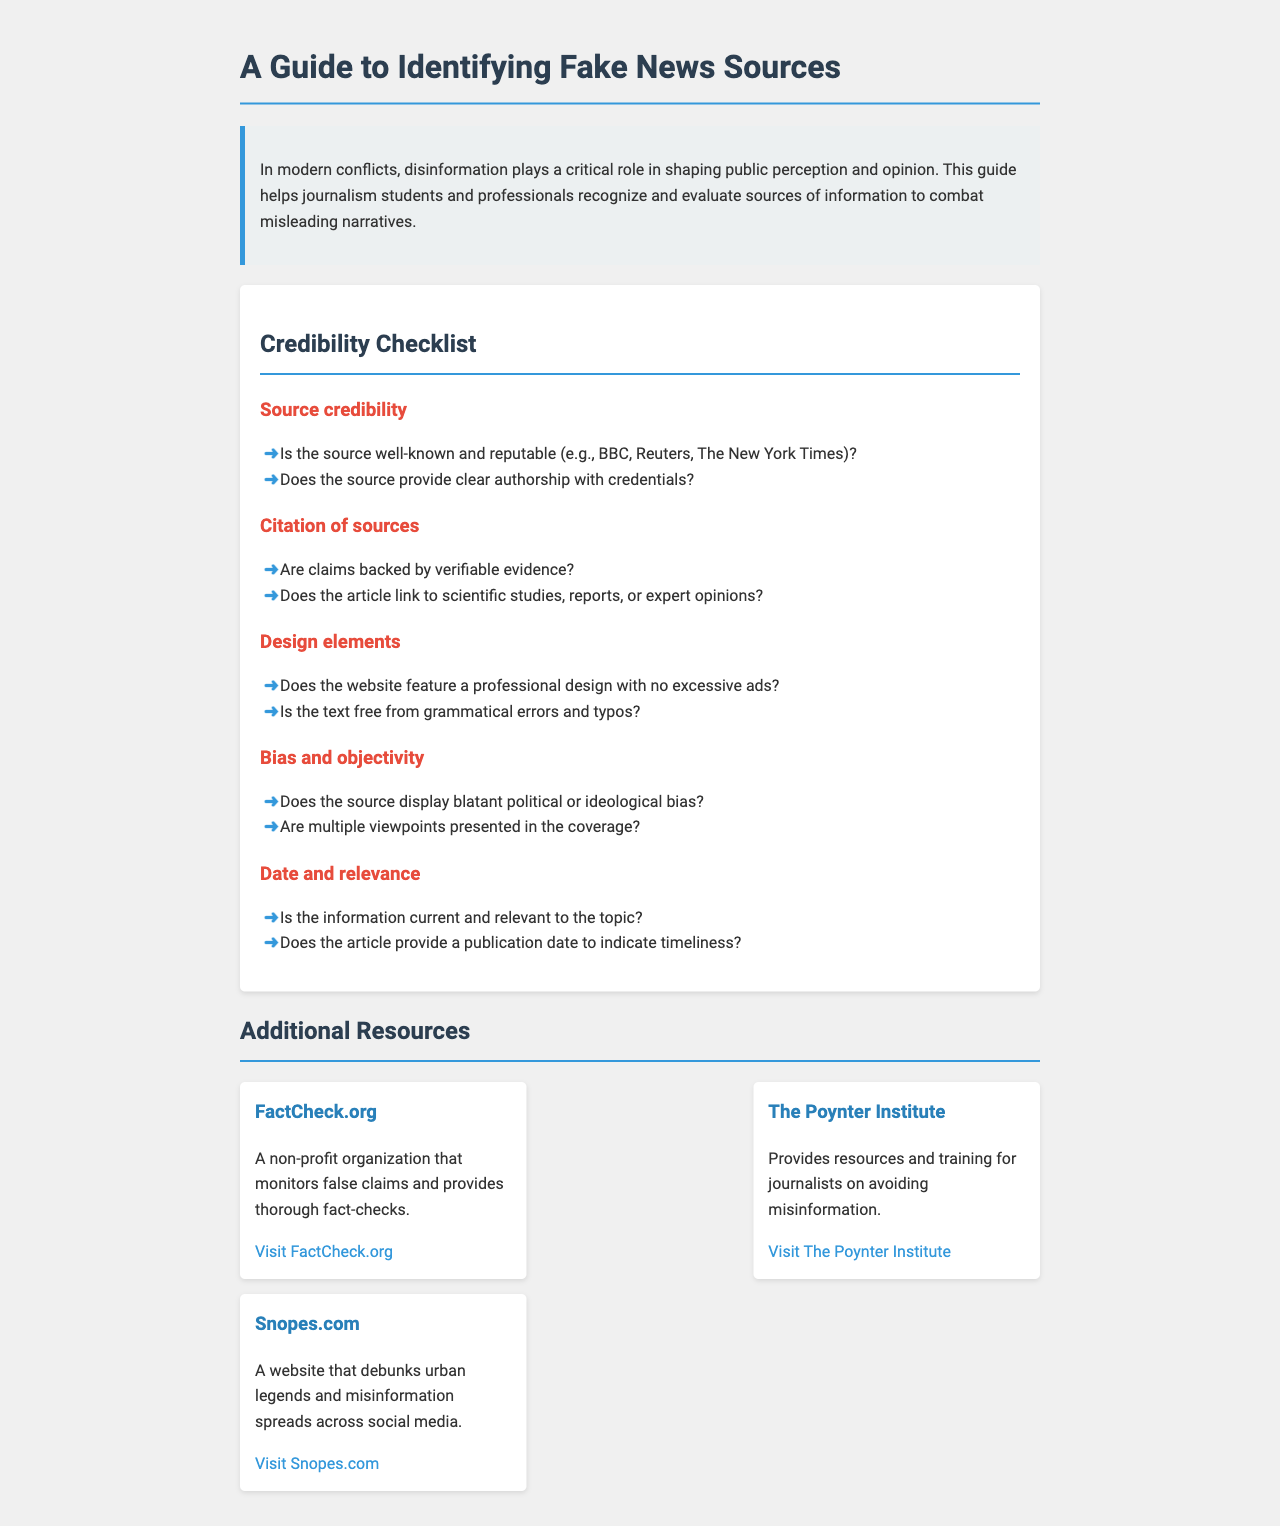What is the title of the document? The title provides the primary subject of the document and is stated at the top.
Answer: A Guide to Identifying Fake News Sources What does the introduction highlight about disinformation? The introduction explains the role of disinformation specifically in modern conflicts.
Answer: It plays a critical role in shaping public perception and opinion Name one of the resources listed in the document. The document provides a list of organizations that help combat misinformation.
Answer: FactCheck.org How many items are in the credibility checklist? The document explicitly indicates the number of checklist items provided under the Credibility Checklist section.
Answer: Five What color is used for headings in the checklist? The checklist uses a consistent color scheme for its headers to maintain design cohesion.
Answer: Red What does a professional website design lack according to the checklist? According to the layout guidelines in the checklist, a professional design should not contain certain elements that detract from credibility.
Answer: Excessive ads What type of bias does the checklist ask the reader to evaluate? The checklist indicates a focus on a specific kind of bias that may influence the information provided.
Answer: Political or ideological bias What should the article provide to indicate timeliness? The checklist suggests a specific piece of information that helps assess whether content is up to date.
Answer: Publication date How does the resource card for Snopes.com describe its purpose? The document gives a brief description of each resource, indicating what specific need they fulfill.
Answer: Debunks urban legends and misinformation spreads across social media 